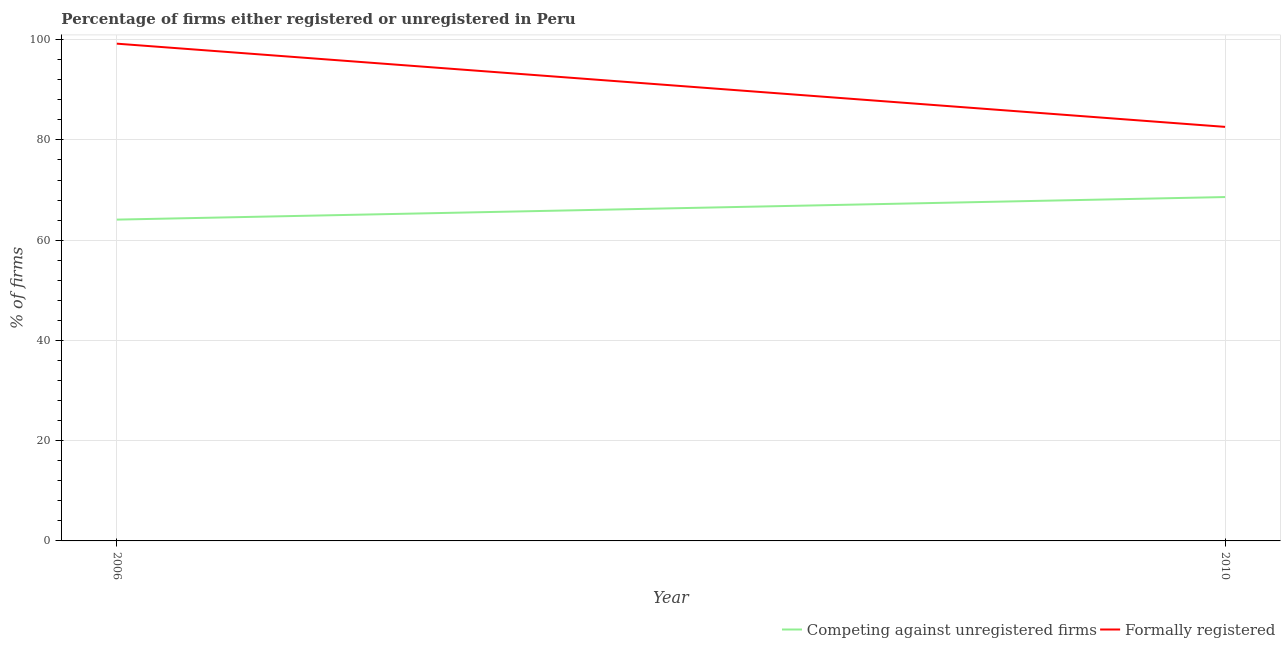Does the line corresponding to percentage of formally registered firms intersect with the line corresponding to percentage of registered firms?
Provide a short and direct response. No. What is the percentage of registered firms in 2006?
Offer a terse response. 64.1. Across all years, what is the maximum percentage of registered firms?
Your response must be concise. 68.6. Across all years, what is the minimum percentage of formally registered firms?
Provide a short and direct response. 82.6. What is the total percentage of registered firms in the graph?
Your answer should be compact. 132.7. What is the difference between the percentage of formally registered firms in 2006 and the percentage of registered firms in 2010?
Offer a very short reply. 30.6. What is the average percentage of registered firms per year?
Your answer should be compact. 66.35. In the year 2006, what is the difference between the percentage of formally registered firms and percentage of registered firms?
Your response must be concise. 35.1. What is the ratio of the percentage of formally registered firms in 2006 to that in 2010?
Make the answer very short. 1.2. In how many years, is the percentage of formally registered firms greater than the average percentage of formally registered firms taken over all years?
Offer a terse response. 1. Does the percentage of registered firms monotonically increase over the years?
Provide a short and direct response. Yes. Is the percentage of formally registered firms strictly greater than the percentage of registered firms over the years?
Provide a succinct answer. Yes. Is the percentage of registered firms strictly less than the percentage of formally registered firms over the years?
Provide a short and direct response. Yes. How many lines are there?
Give a very brief answer. 2. How many years are there in the graph?
Offer a very short reply. 2. Does the graph contain grids?
Keep it short and to the point. Yes. How are the legend labels stacked?
Offer a very short reply. Horizontal. What is the title of the graph?
Provide a succinct answer. Percentage of firms either registered or unregistered in Peru. What is the label or title of the X-axis?
Keep it short and to the point. Year. What is the label or title of the Y-axis?
Give a very brief answer. % of firms. What is the % of firms of Competing against unregistered firms in 2006?
Give a very brief answer. 64.1. What is the % of firms of Formally registered in 2006?
Your response must be concise. 99.2. What is the % of firms in Competing against unregistered firms in 2010?
Provide a succinct answer. 68.6. What is the % of firms in Formally registered in 2010?
Offer a very short reply. 82.6. Across all years, what is the maximum % of firms of Competing against unregistered firms?
Ensure brevity in your answer.  68.6. Across all years, what is the maximum % of firms in Formally registered?
Your answer should be very brief. 99.2. Across all years, what is the minimum % of firms of Competing against unregistered firms?
Give a very brief answer. 64.1. Across all years, what is the minimum % of firms in Formally registered?
Give a very brief answer. 82.6. What is the total % of firms in Competing against unregistered firms in the graph?
Offer a very short reply. 132.7. What is the total % of firms in Formally registered in the graph?
Your answer should be very brief. 181.8. What is the difference between the % of firms of Competing against unregistered firms in 2006 and that in 2010?
Provide a short and direct response. -4.5. What is the difference between the % of firms of Competing against unregistered firms in 2006 and the % of firms of Formally registered in 2010?
Offer a very short reply. -18.5. What is the average % of firms in Competing against unregistered firms per year?
Your answer should be very brief. 66.35. What is the average % of firms of Formally registered per year?
Provide a short and direct response. 90.9. In the year 2006, what is the difference between the % of firms in Competing against unregistered firms and % of firms in Formally registered?
Offer a terse response. -35.1. What is the ratio of the % of firms of Competing against unregistered firms in 2006 to that in 2010?
Offer a terse response. 0.93. What is the ratio of the % of firms of Formally registered in 2006 to that in 2010?
Offer a terse response. 1.2. What is the difference between the highest and the second highest % of firms of Formally registered?
Your answer should be very brief. 16.6. What is the difference between the highest and the lowest % of firms in Competing against unregistered firms?
Offer a very short reply. 4.5. What is the difference between the highest and the lowest % of firms of Formally registered?
Give a very brief answer. 16.6. 